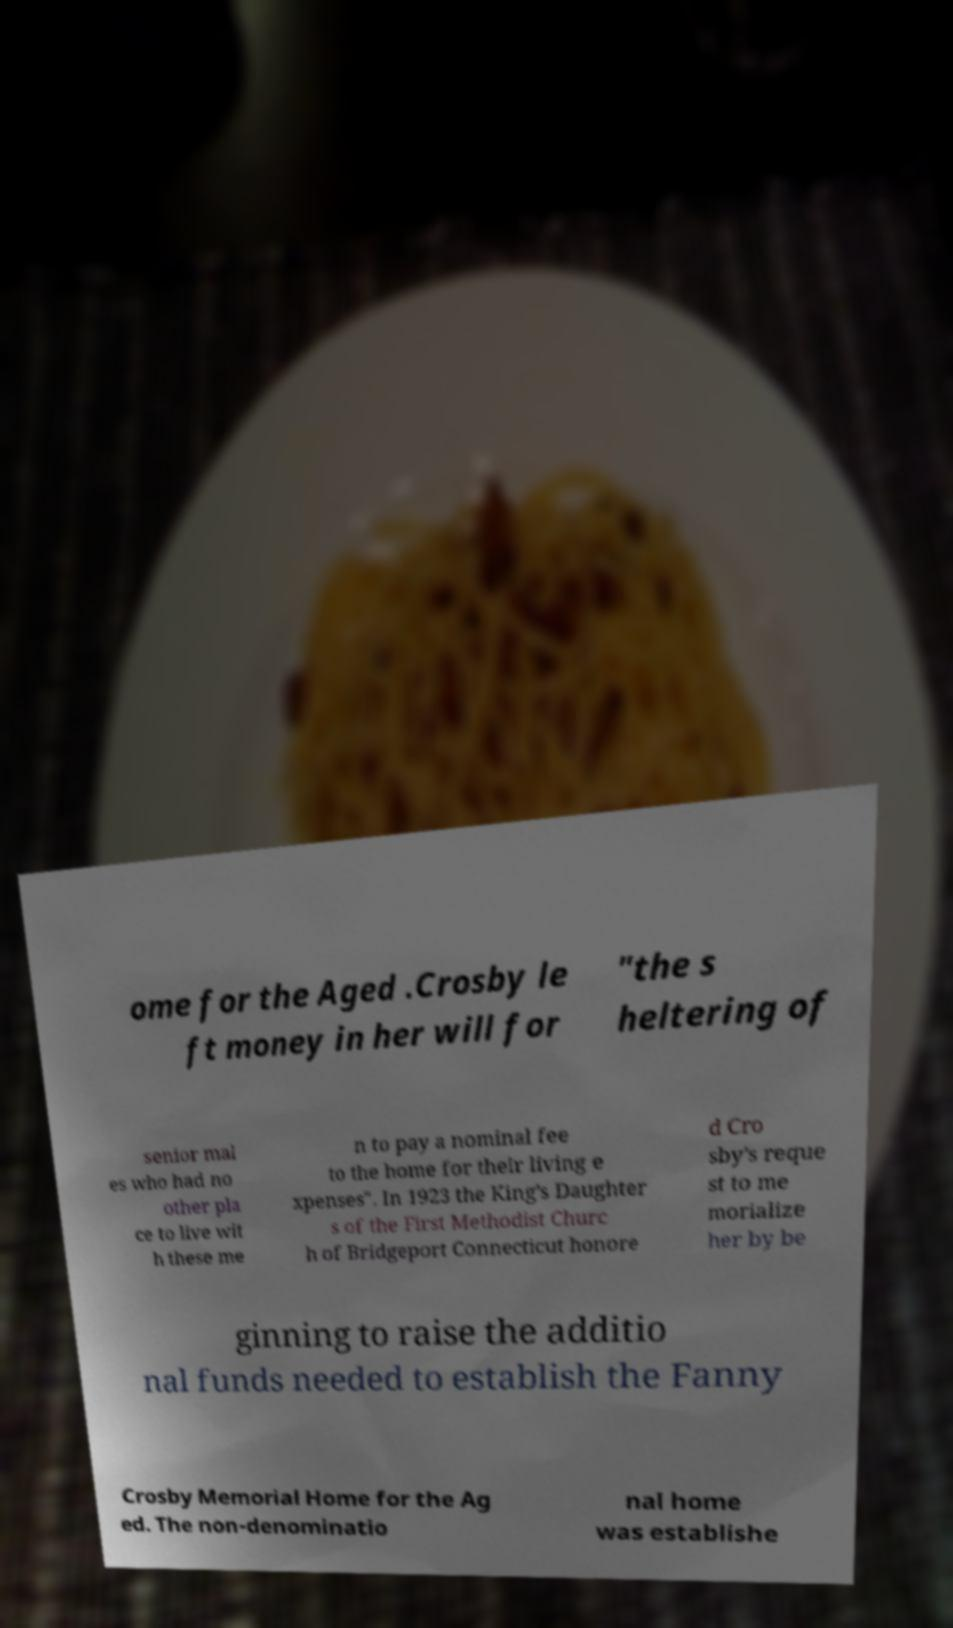Please read and relay the text visible in this image. What does it say? ome for the Aged .Crosby le ft money in her will for "the s heltering of senior mal es who had no other pla ce to live wit h these me n to pay a nominal fee to the home for their living e xpenses". In 1923 the King's Daughter s of the First Methodist Churc h of Bridgeport Connecticut honore d Cro sby's reque st to me morialize her by be ginning to raise the additio nal funds needed to establish the Fanny Crosby Memorial Home for the Ag ed. The non-denominatio nal home was establishe 